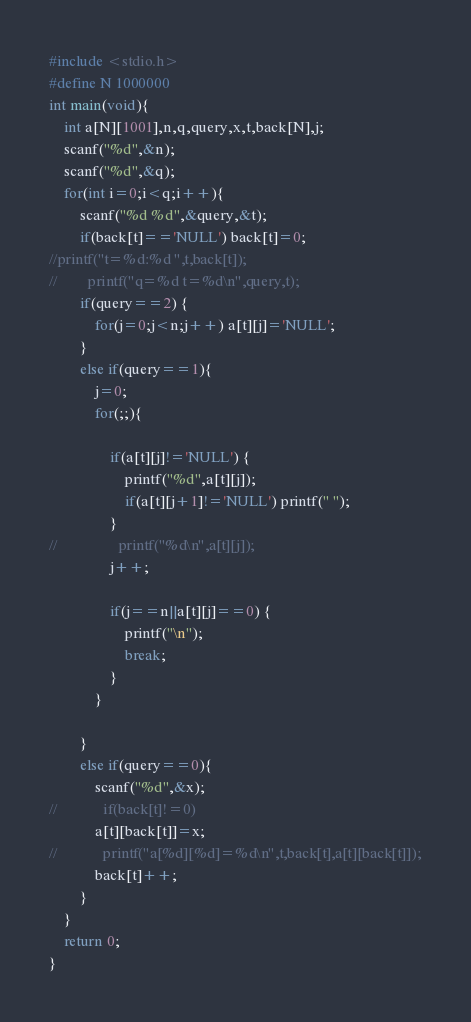<code> <loc_0><loc_0><loc_500><loc_500><_C_>#include <stdio.h>
#define N 1000000
int main(void){
    int a[N][1001],n,q,query,x,t,back[N],j;
    scanf("%d",&n);
    scanf("%d",&q);
    for(int i=0;i<q;i++){
        scanf("%d %d",&query,&t);
        if(back[t]=='NULL') back[t]=0;
//printf("t=%d:%d ",t,back[t]);
//        printf("q=%d t=%d\n",query,t);
        if(query==2) {
            for(j=0;j<n;j++) a[t][j]='NULL';
        }
        else if(query==1){
            j=0;
            for(;;){

                if(a[t][j]!='NULL') {
                    printf("%d",a[t][j]);
                    if(a[t][j+1]!='NULL') printf(" ");
                }
//                printf("%d\n",a[t][j]);
                j++;
                
                if(j==n||a[t][j]==0) {
                    printf("\n");
                    break;
                }
            }

        }
        else if(query==0){
            scanf("%d",&x);
//            if(back[t]!=0) 
            a[t][back[t]]=x;
//            printf("a[%d][%d]=%d\n",t,back[t],a[t][back[t]]);
            back[t]++;
        }
    }
    return 0;
}

</code> 